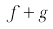Convert formula to latex. <formula><loc_0><loc_0><loc_500><loc_500>f + g</formula> 